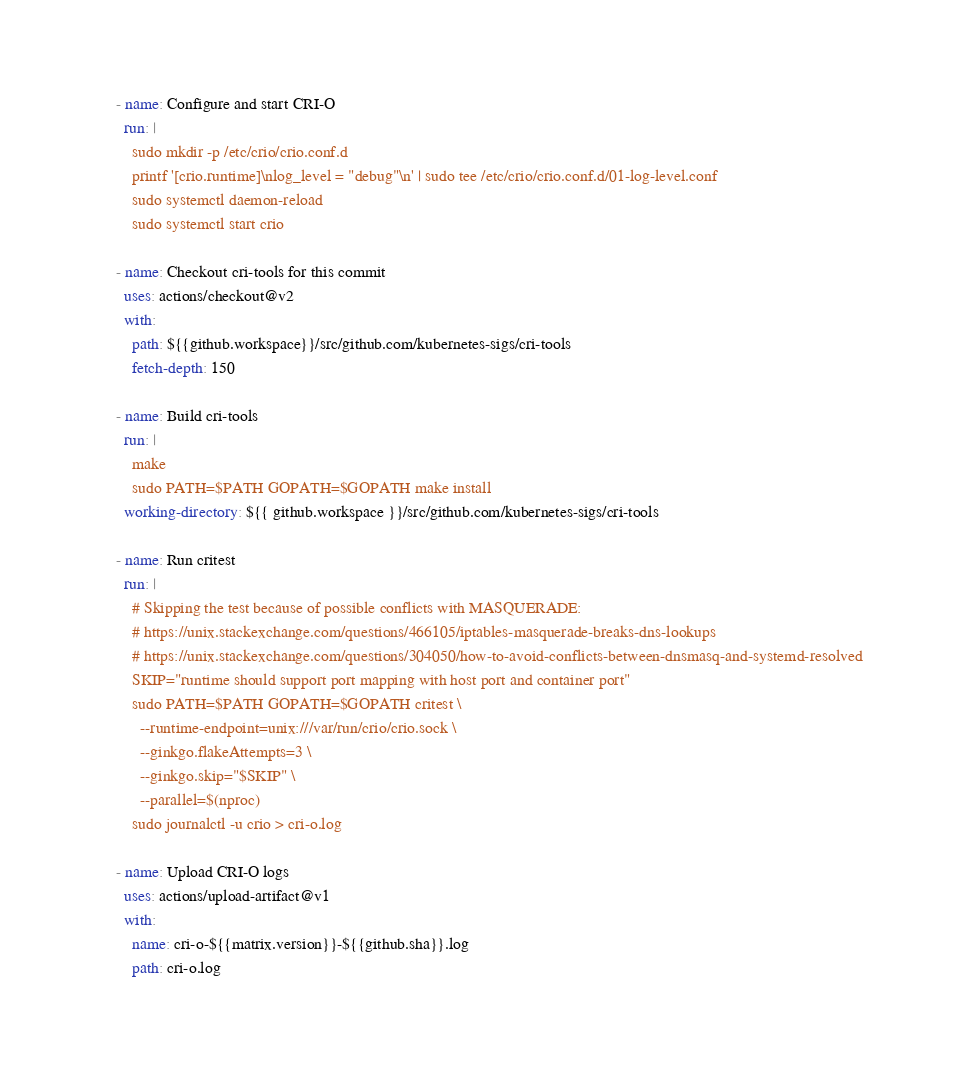Convert code to text. <code><loc_0><loc_0><loc_500><loc_500><_YAML_>
      - name: Configure and start CRI-O
        run: |
          sudo mkdir -p /etc/crio/crio.conf.d
          printf '[crio.runtime]\nlog_level = "debug"\n' | sudo tee /etc/crio/crio.conf.d/01-log-level.conf
          sudo systemctl daemon-reload
          sudo systemctl start crio

      - name: Checkout cri-tools for this commit
        uses: actions/checkout@v2
        with:
          path: ${{github.workspace}}/src/github.com/kubernetes-sigs/cri-tools
          fetch-depth: 150

      - name: Build cri-tools
        run: |
          make
          sudo PATH=$PATH GOPATH=$GOPATH make install
        working-directory: ${{ github.workspace }}/src/github.com/kubernetes-sigs/cri-tools

      - name: Run critest
        run: |
          # Skipping the test because of possible conflicts with MASQUERADE:
          # https://unix.stackexchange.com/questions/466105/iptables-masquerade-breaks-dns-lookups
          # https://unix.stackexchange.com/questions/304050/how-to-avoid-conflicts-between-dnsmasq-and-systemd-resolved
          SKIP="runtime should support port mapping with host port and container port"
          sudo PATH=$PATH GOPATH=$GOPATH critest \
            --runtime-endpoint=unix:///var/run/crio/crio.sock \
            --ginkgo.flakeAttempts=3 \
            --ginkgo.skip="$SKIP" \
            --parallel=$(nproc)
          sudo journalctl -u crio > cri-o.log

      - name: Upload CRI-O logs
        uses: actions/upload-artifact@v1
        with:
          name: cri-o-${{matrix.version}}-${{github.sha}}.log
          path: cri-o.log
</code> 